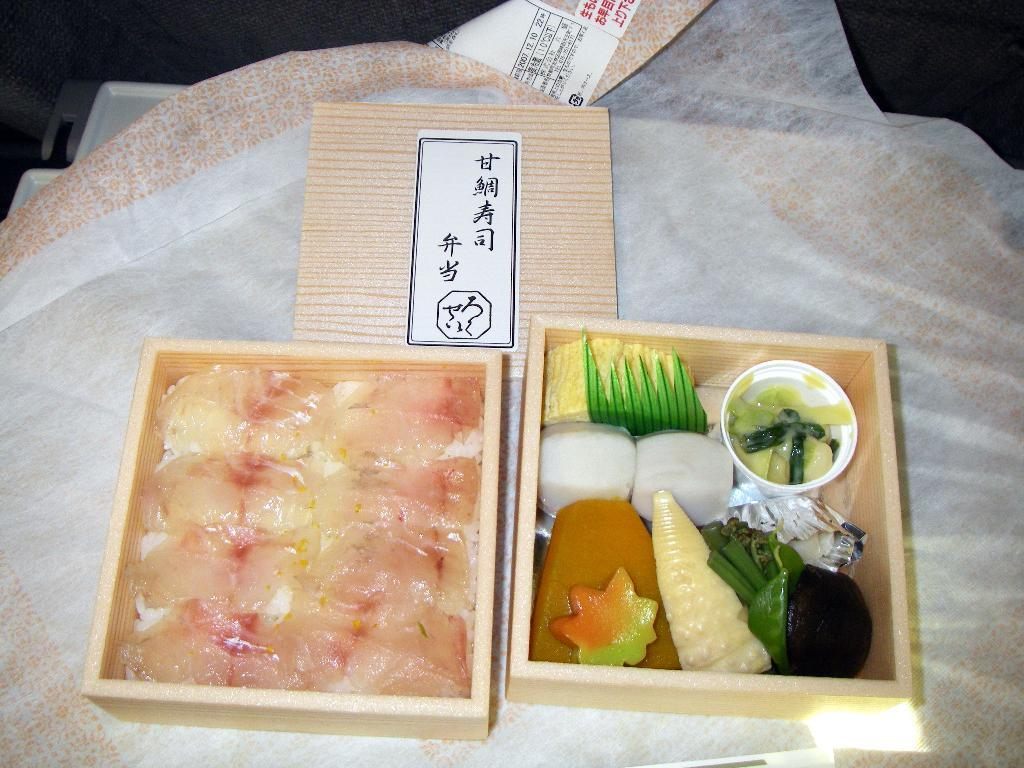What types of items are present in the image? There are food items in the image. How are the food items organized or stored? The food items are kept in two boxes. What is placed under the food items? There is a cloth under the food items. How many trees can be seen in the image? There are no trees visible in the image; it only contains food items, boxes, and a cloth. 